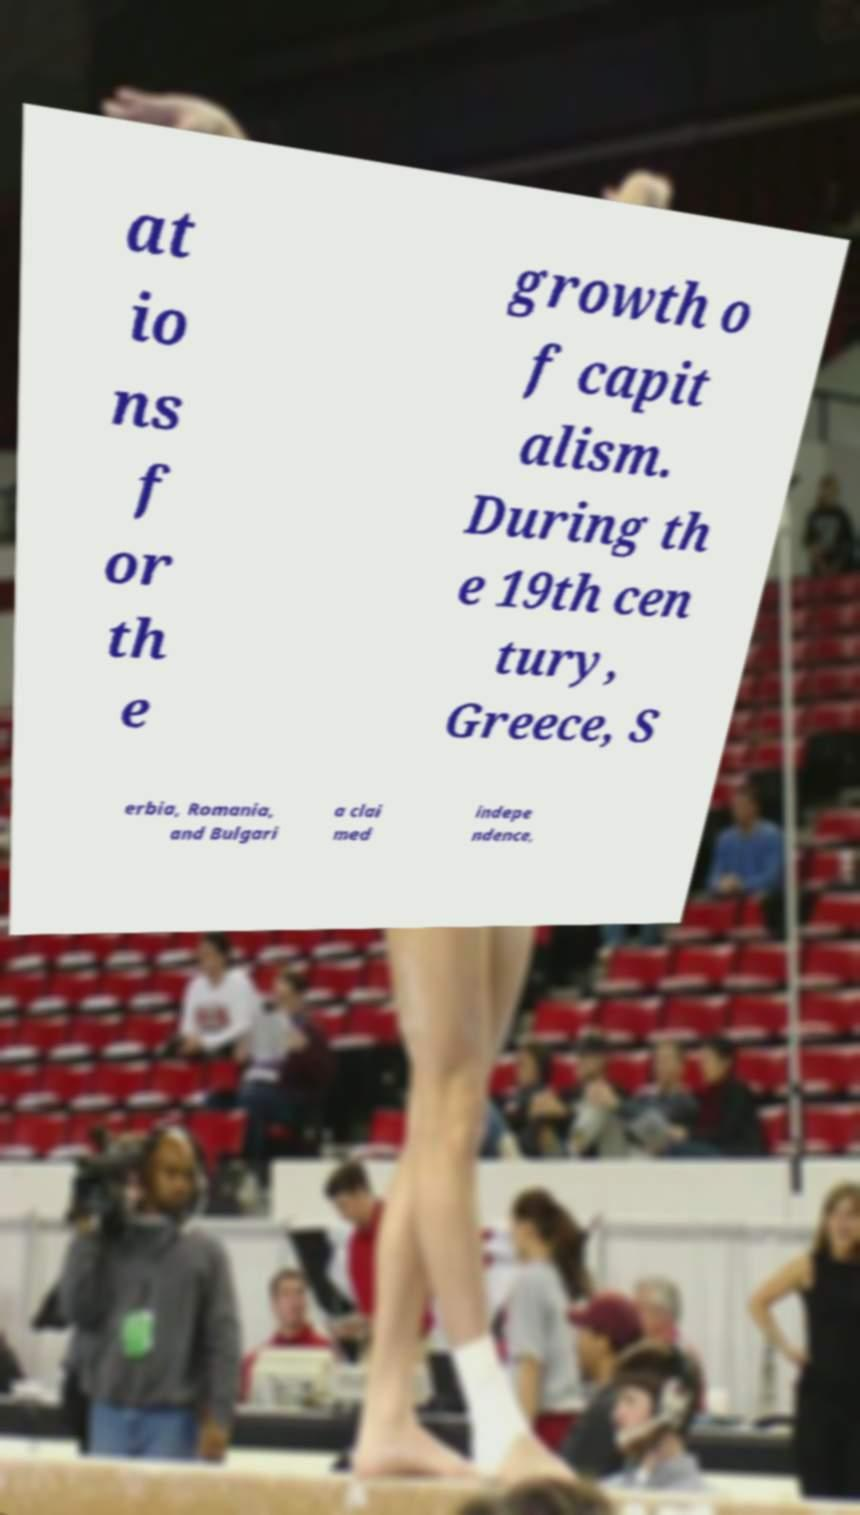Can you read and provide the text displayed in the image?This photo seems to have some interesting text. Can you extract and type it out for me? at io ns f or th e growth o f capit alism. During th e 19th cen tury, Greece, S erbia, Romania, and Bulgari a clai med indepe ndence, 